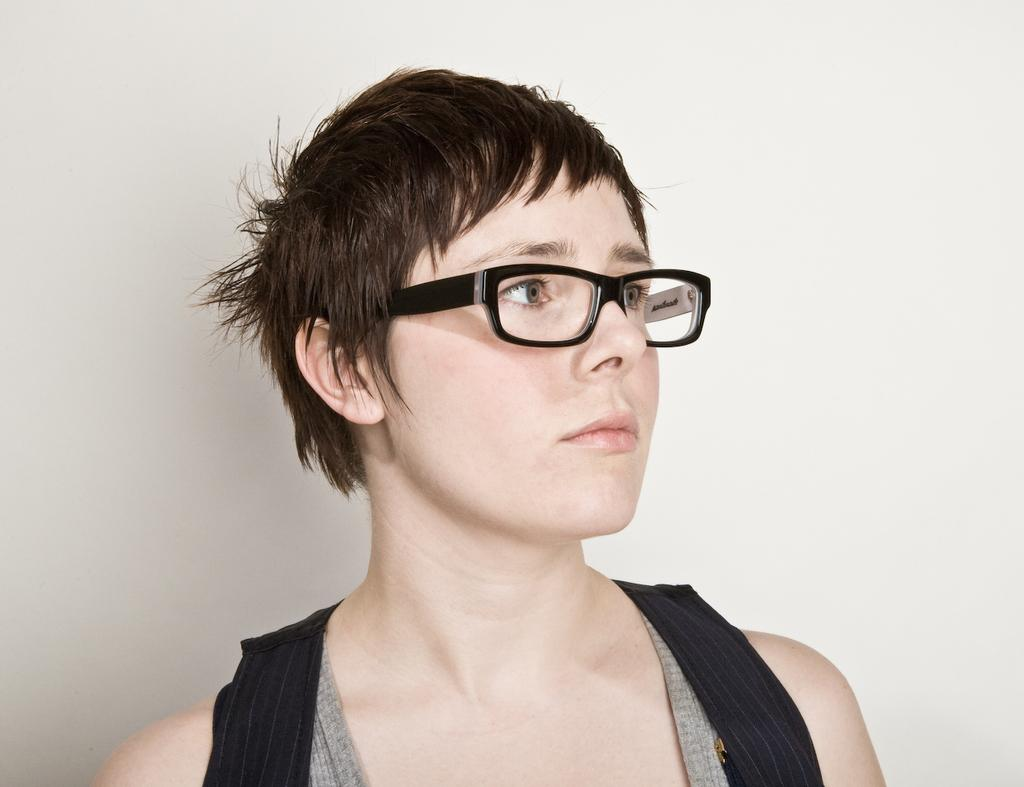Who is the main subject in the image? There is a woman in the image. What is the woman wearing on her face? The woman is wearing a spectacle. What colors are present in the woman's dress? The woman is wearing a black and grey color dress. What is the color of the background in the image? The background of the image is white. What type of lumber can be seen stacked in the background of the image? There is no lumber present in the image; the background is white. How many letters are visible on the woman's dress in the image? There are no letters visible on the woman's dress in the image; it is a black and grey color dress. 